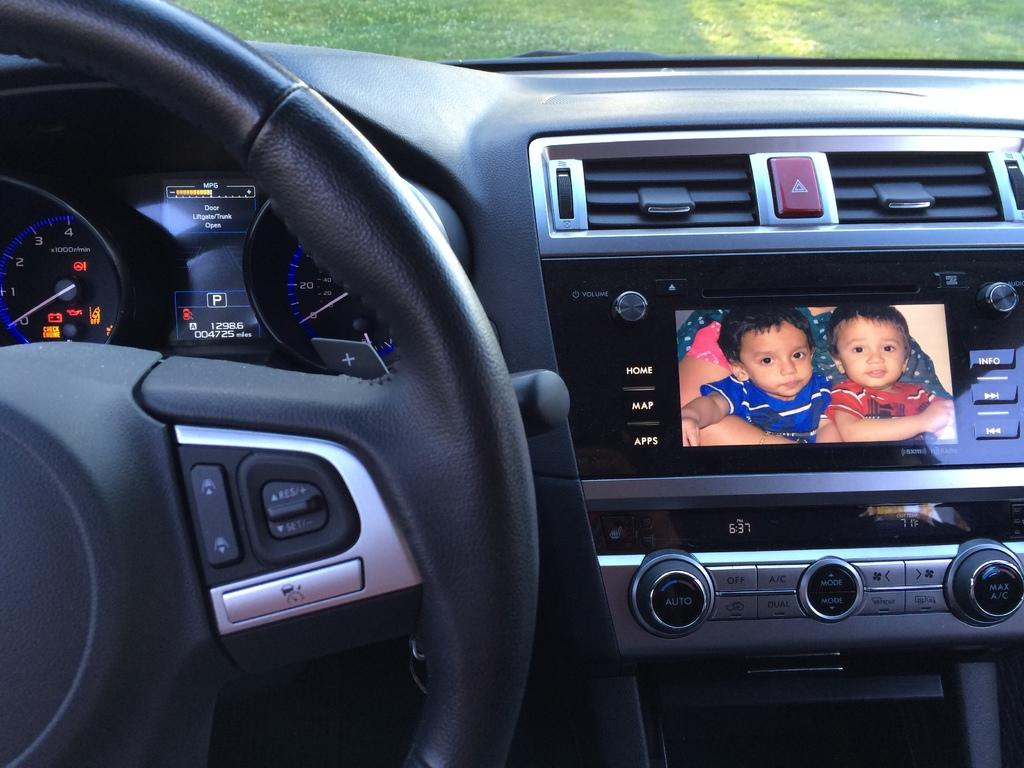What type of location is depicted in the image? The image is of the inside of a vehicle. What instruments are present in the vehicle for monitoring or control? There are meters visible in the vehicle. What is used for steering the vehicle? A steering wheel is present in the vehicle. What device is available for entertainment in the vehicle? There is a music player in the vehicle. What type of environment can be seen through the windows of the vehicle? Grass is visible in the image. Is there a sofa in the vehicle? No, there is no sofa present in the vehicle; the image shows the interior of a vehicle with a steering wheel, meters, and a music player. 